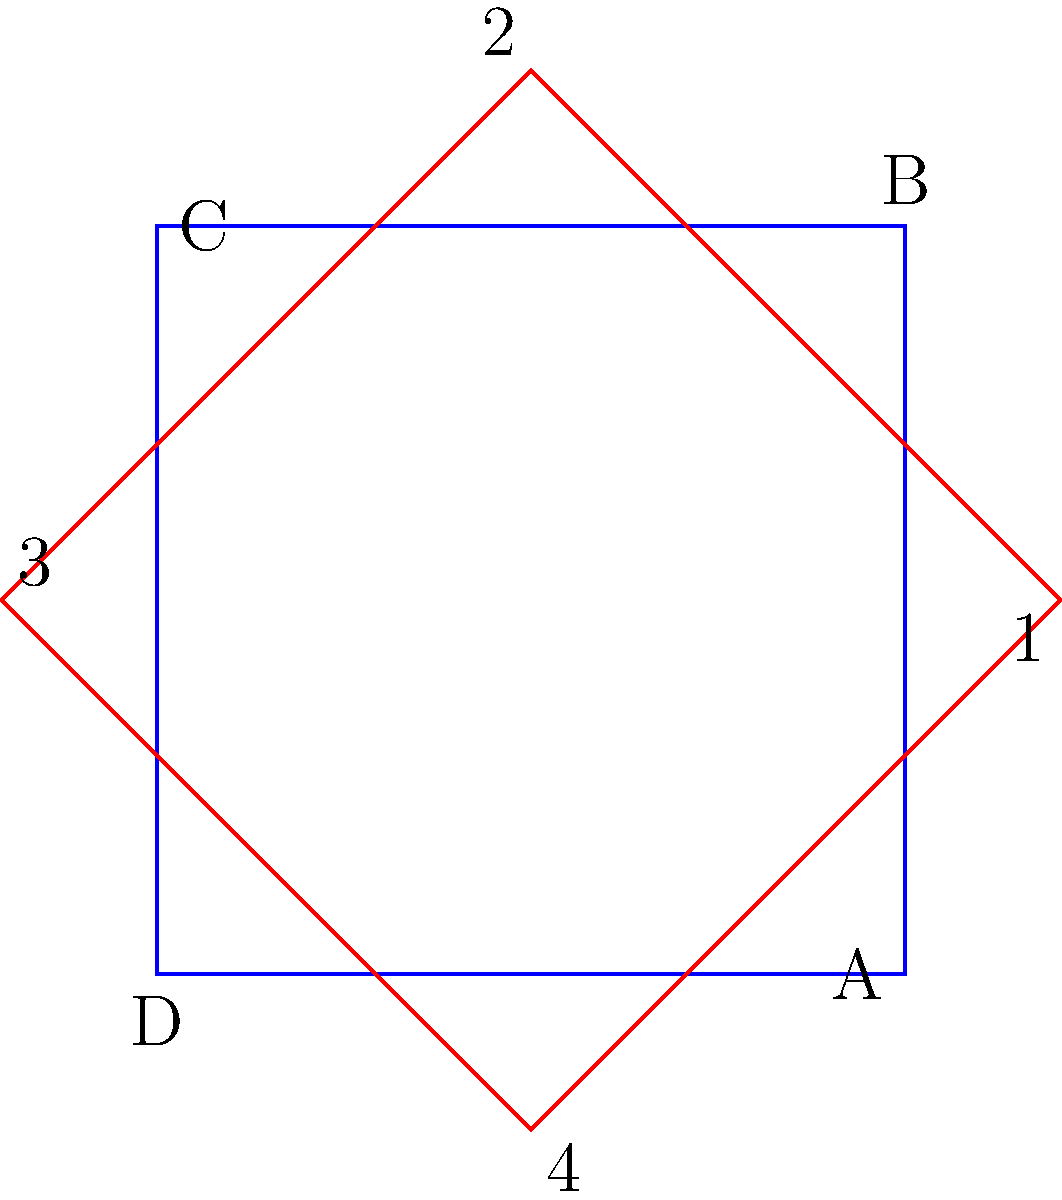In Elizabethan manor houses, the layout of rooms often followed a symmetrical pattern. If the blue square represents the original floor plan of a manor house, and the red square shows a rotated version, which corner of the original plan (A, B, C, or D) corresponds to corner 3 in the rotated plan? To solve this problem, we need to mentally rotate the blue square to align with the red square. Let's follow these steps:

1. Observe that the red square is rotated 45 degrees clockwise from the blue square.
2. Identify that corner 3 in the red square is in the top-right position.
3. Mentally rotate the blue square 45 degrees clockwise:
   - Corner A would move towards the bottom-left
   - Corner B would move towards the top-left
   - Corner C would move towards the top-right
   - Corner D would move towards the bottom-right
4. After rotation, we can see that corner C of the original blue square aligns with corner 3 of the red square.

This mental rotation exercise is similar to how historians might analyze the evolution of room layouts in Elizabethan manor houses, such as those designed by Bess of Hardwick at Hardwick Hall.
Answer: C 